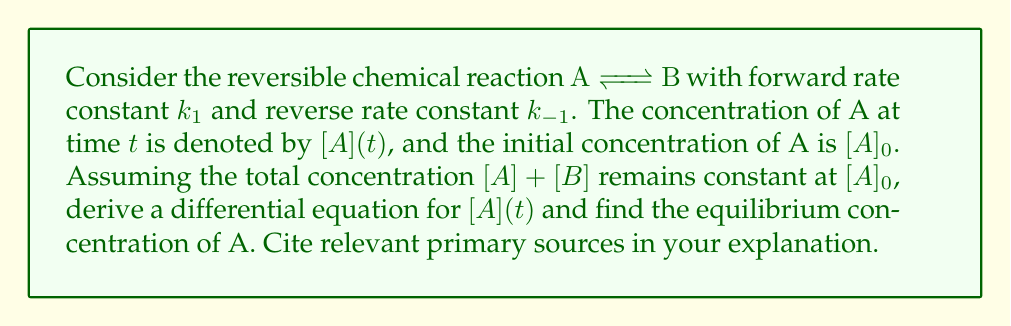Help me with this question. 1. Let's start by writing the rate equation for the change in concentration of A:

   $$\frac{d[A]}{dt} = -k_1[A] + k_{-1}[B]$$

2. Since the total concentration remains constant, we can express [B] in terms of [A]:

   $$[B] = [A]_0 - [A]$$

3. Substituting this into our rate equation:

   $$\frac{d[A]}{dt} = -k_1[A] + k_{-1}([A]_0 - [A])$$

4. Simplifying:

   $$\frac{d[A]}{dt} = -k_1[A] + k_{-1}[A]_0 - k_{-1}[A] = k_{-1}[A]_0 - (k_1 + k_{-1})[A]$$

5. At equilibrium, the rate of change is zero:

   $$0 = k_{-1}[A]_0 - (k_1 + k_{-1})[A]_{eq}$$

6. Solving for $[A]_{eq}$:

   $$[A]_{eq} = \frac{k_{-1}[A]_0}{k_1 + k_{-1}}$$

This result is consistent with the law of mass action, first proposed by Guldberg and Waage in 1864 (Waage, P. & Guldberg, C.M. "Studies Concerning Affinity" Forhandlinger: Videnskabs-Selskabet i Christiana (1864): 35).

7. We can also express this in terms of the equilibrium constant $K_{eq} = \frac{k_1}{k_{-1}}$:

   $$[A]_{eq} = \frac{[A]_0}{1 + K_{eq}}$$

This form is particularly useful in chemical thermodynamics, as discussed by Gilbert N. Lewis in his seminal work "A New System of Chemical Thermodynamics" (Proceedings of the American Academy of Arts and Sciences, 1907).
Answer: $[A]_{eq} = \frac{k_{-1}[A]_0}{k_1 + k_{-1}}$ or $[A]_{eq} = \frac{[A]_0}{1 + K_{eq}}$ 